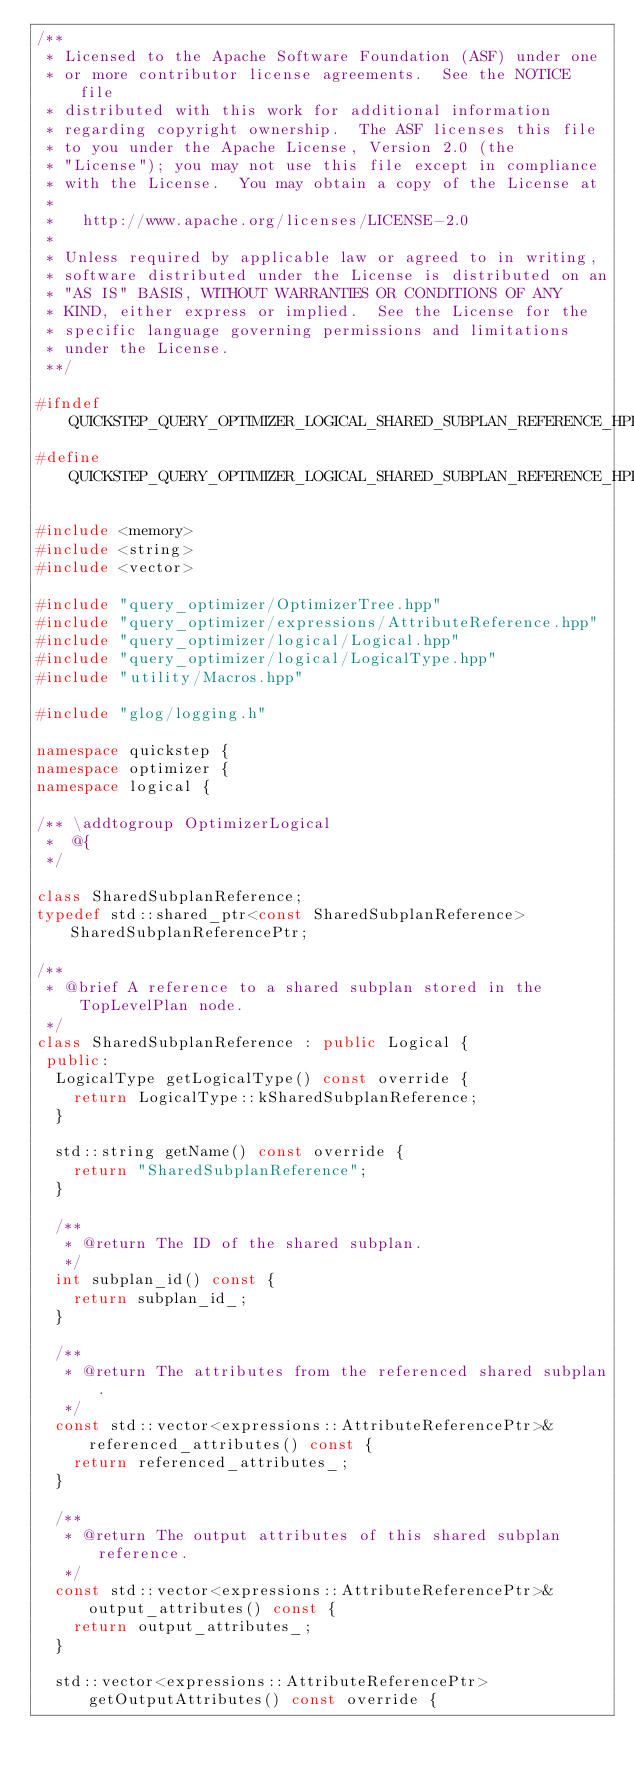Convert code to text. <code><loc_0><loc_0><loc_500><loc_500><_C++_>/**
 * Licensed to the Apache Software Foundation (ASF) under one
 * or more contributor license agreements.  See the NOTICE file
 * distributed with this work for additional information
 * regarding copyright ownership.  The ASF licenses this file
 * to you under the Apache License, Version 2.0 (the
 * "License"); you may not use this file except in compliance
 * with the License.  You may obtain a copy of the License at
 *
 *   http://www.apache.org/licenses/LICENSE-2.0
 *
 * Unless required by applicable law or agreed to in writing,
 * software distributed under the License is distributed on an
 * "AS IS" BASIS, WITHOUT WARRANTIES OR CONDITIONS OF ANY
 * KIND, either express or implied.  See the License for the
 * specific language governing permissions and limitations
 * under the License.
 **/

#ifndef QUICKSTEP_QUERY_OPTIMIZER_LOGICAL_SHARED_SUBPLAN_REFERENCE_HPP_
#define QUICKSTEP_QUERY_OPTIMIZER_LOGICAL_SHARED_SUBPLAN_REFERENCE_HPP_

#include <memory>
#include <string>
#include <vector>

#include "query_optimizer/OptimizerTree.hpp"
#include "query_optimizer/expressions/AttributeReference.hpp"
#include "query_optimizer/logical/Logical.hpp"
#include "query_optimizer/logical/LogicalType.hpp"
#include "utility/Macros.hpp"

#include "glog/logging.h"

namespace quickstep {
namespace optimizer {
namespace logical {

/** \addtogroup OptimizerLogical
 *  @{
 */

class SharedSubplanReference;
typedef std::shared_ptr<const SharedSubplanReference> SharedSubplanReferencePtr;

/**
 * @brief A reference to a shared subplan stored in the TopLevelPlan node.
 */
class SharedSubplanReference : public Logical {
 public:
  LogicalType getLogicalType() const override {
    return LogicalType::kSharedSubplanReference;
  }

  std::string getName() const override {
    return "SharedSubplanReference";
  }

  /**
   * @return The ID of the shared subplan.
   */
  int subplan_id() const {
    return subplan_id_;
  }

  /**
   * @return The attributes from the referenced shared subplan.
   */
  const std::vector<expressions::AttributeReferencePtr>& referenced_attributes() const {
    return referenced_attributes_;
  }

  /**
   * @return The output attributes of this shared subplan reference.
   */
  const std::vector<expressions::AttributeReferencePtr>& output_attributes() const {
    return output_attributes_;
  }

  std::vector<expressions::AttributeReferencePtr> getOutputAttributes() const override {</code> 